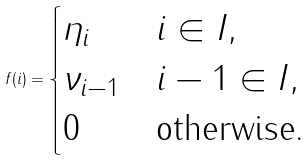<formula> <loc_0><loc_0><loc_500><loc_500>f ( i ) = \begin{cases} \eta _ { i } & i \in I , \\ \nu _ { i - 1 } & i - 1 \in I , \\ 0 & \text {otherwise.} \end{cases}</formula> 